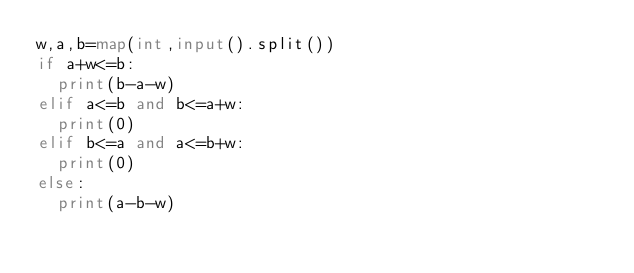Convert code to text. <code><loc_0><loc_0><loc_500><loc_500><_Python_>w,a,b=map(int,input().split())
if a+w<=b:
  print(b-a-w)
elif a<=b and b<=a+w:
  print(0)
elif b<=a and a<=b+w:
  print(0)
else:
  print(a-b-w)</code> 